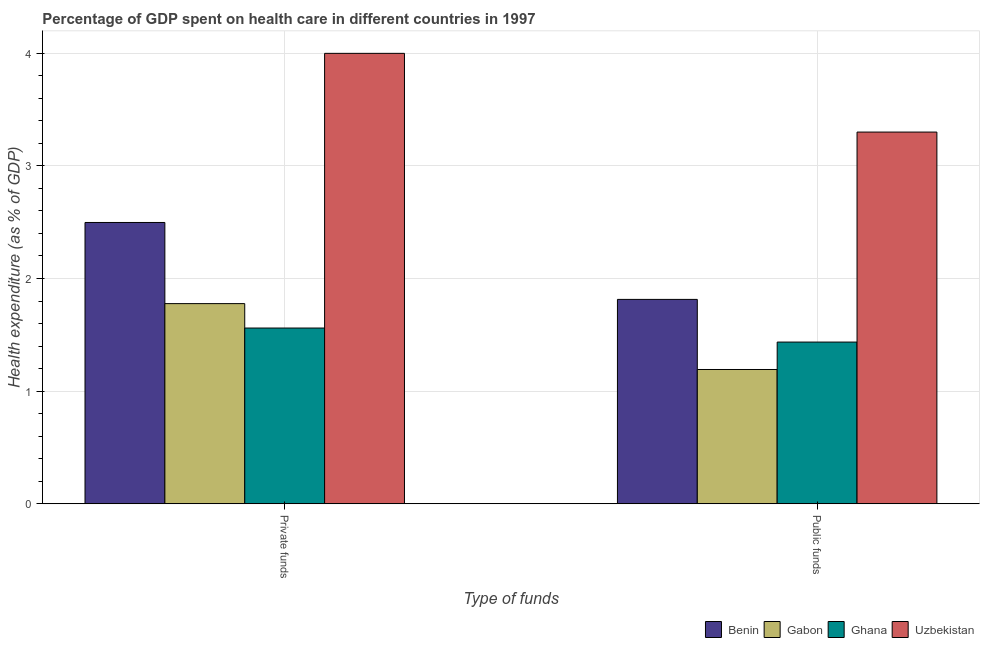How many different coloured bars are there?
Your response must be concise. 4. Are the number of bars per tick equal to the number of legend labels?
Provide a succinct answer. Yes. Are the number of bars on each tick of the X-axis equal?
Give a very brief answer. Yes. How many bars are there on the 2nd tick from the left?
Make the answer very short. 4. What is the label of the 2nd group of bars from the left?
Provide a succinct answer. Public funds. What is the amount of private funds spent in healthcare in Uzbekistan?
Your response must be concise. 4. Across all countries, what is the maximum amount of private funds spent in healthcare?
Ensure brevity in your answer.  4. Across all countries, what is the minimum amount of public funds spent in healthcare?
Your response must be concise. 1.19. In which country was the amount of public funds spent in healthcare maximum?
Your answer should be compact. Uzbekistan. What is the total amount of public funds spent in healthcare in the graph?
Ensure brevity in your answer.  7.74. What is the difference between the amount of private funds spent in healthcare in Benin and that in Ghana?
Give a very brief answer. 0.94. What is the difference between the amount of public funds spent in healthcare in Benin and the amount of private funds spent in healthcare in Uzbekistan?
Make the answer very short. -2.18. What is the average amount of public funds spent in healthcare per country?
Keep it short and to the point. 1.94. What is the difference between the amount of public funds spent in healthcare and amount of private funds spent in healthcare in Benin?
Ensure brevity in your answer.  -0.68. In how many countries, is the amount of private funds spent in healthcare greater than 2.6 %?
Provide a succinct answer. 1. What is the ratio of the amount of public funds spent in healthcare in Ghana to that in Benin?
Offer a terse response. 0.79. Is the amount of private funds spent in healthcare in Ghana less than that in Benin?
Keep it short and to the point. Yes. In how many countries, is the amount of public funds spent in healthcare greater than the average amount of public funds spent in healthcare taken over all countries?
Offer a terse response. 1. What does the 2nd bar from the left in Public funds represents?
Ensure brevity in your answer.  Gabon. What does the 3rd bar from the right in Private funds represents?
Ensure brevity in your answer.  Gabon. Are all the bars in the graph horizontal?
Provide a succinct answer. No. How many countries are there in the graph?
Offer a terse response. 4. Does the graph contain grids?
Offer a very short reply. Yes. Where does the legend appear in the graph?
Provide a succinct answer. Bottom right. How many legend labels are there?
Give a very brief answer. 4. How are the legend labels stacked?
Provide a succinct answer. Horizontal. What is the title of the graph?
Give a very brief answer. Percentage of GDP spent on health care in different countries in 1997. Does "Czech Republic" appear as one of the legend labels in the graph?
Provide a short and direct response. No. What is the label or title of the X-axis?
Your answer should be compact. Type of funds. What is the label or title of the Y-axis?
Provide a short and direct response. Health expenditure (as % of GDP). What is the Health expenditure (as % of GDP) of Benin in Private funds?
Ensure brevity in your answer.  2.5. What is the Health expenditure (as % of GDP) in Gabon in Private funds?
Your answer should be compact. 1.78. What is the Health expenditure (as % of GDP) in Ghana in Private funds?
Your response must be concise. 1.56. What is the Health expenditure (as % of GDP) of Uzbekistan in Private funds?
Offer a terse response. 4. What is the Health expenditure (as % of GDP) in Benin in Public funds?
Give a very brief answer. 1.81. What is the Health expenditure (as % of GDP) in Gabon in Public funds?
Your answer should be very brief. 1.19. What is the Health expenditure (as % of GDP) of Ghana in Public funds?
Provide a short and direct response. 1.44. What is the Health expenditure (as % of GDP) in Uzbekistan in Public funds?
Give a very brief answer. 3.3. Across all Type of funds, what is the maximum Health expenditure (as % of GDP) of Benin?
Keep it short and to the point. 2.5. Across all Type of funds, what is the maximum Health expenditure (as % of GDP) of Gabon?
Offer a terse response. 1.78. Across all Type of funds, what is the maximum Health expenditure (as % of GDP) in Ghana?
Keep it short and to the point. 1.56. Across all Type of funds, what is the maximum Health expenditure (as % of GDP) in Uzbekistan?
Your answer should be very brief. 4. Across all Type of funds, what is the minimum Health expenditure (as % of GDP) in Benin?
Make the answer very short. 1.81. Across all Type of funds, what is the minimum Health expenditure (as % of GDP) in Gabon?
Offer a very short reply. 1.19. Across all Type of funds, what is the minimum Health expenditure (as % of GDP) in Ghana?
Provide a short and direct response. 1.44. Across all Type of funds, what is the minimum Health expenditure (as % of GDP) of Uzbekistan?
Your answer should be compact. 3.3. What is the total Health expenditure (as % of GDP) of Benin in the graph?
Your answer should be very brief. 4.31. What is the total Health expenditure (as % of GDP) of Gabon in the graph?
Give a very brief answer. 2.97. What is the total Health expenditure (as % of GDP) in Ghana in the graph?
Keep it short and to the point. 3. What is the total Health expenditure (as % of GDP) of Uzbekistan in the graph?
Your answer should be compact. 7.3. What is the difference between the Health expenditure (as % of GDP) in Benin in Private funds and that in Public funds?
Your answer should be very brief. 0.68. What is the difference between the Health expenditure (as % of GDP) in Gabon in Private funds and that in Public funds?
Ensure brevity in your answer.  0.58. What is the difference between the Health expenditure (as % of GDP) in Ghana in Private funds and that in Public funds?
Provide a succinct answer. 0.12. What is the difference between the Health expenditure (as % of GDP) in Uzbekistan in Private funds and that in Public funds?
Your answer should be very brief. 0.7. What is the difference between the Health expenditure (as % of GDP) in Benin in Private funds and the Health expenditure (as % of GDP) in Gabon in Public funds?
Provide a succinct answer. 1.31. What is the difference between the Health expenditure (as % of GDP) of Benin in Private funds and the Health expenditure (as % of GDP) of Ghana in Public funds?
Offer a terse response. 1.06. What is the difference between the Health expenditure (as % of GDP) in Benin in Private funds and the Health expenditure (as % of GDP) in Uzbekistan in Public funds?
Offer a very short reply. -0.8. What is the difference between the Health expenditure (as % of GDP) in Gabon in Private funds and the Health expenditure (as % of GDP) in Ghana in Public funds?
Your answer should be compact. 0.34. What is the difference between the Health expenditure (as % of GDP) in Gabon in Private funds and the Health expenditure (as % of GDP) in Uzbekistan in Public funds?
Make the answer very short. -1.52. What is the difference between the Health expenditure (as % of GDP) of Ghana in Private funds and the Health expenditure (as % of GDP) of Uzbekistan in Public funds?
Ensure brevity in your answer.  -1.74. What is the average Health expenditure (as % of GDP) of Benin per Type of funds?
Your answer should be very brief. 2.16. What is the average Health expenditure (as % of GDP) in Gabon per Type of funds?
Make the answer very short. 1.48. What is the average Health expenditure (as % of GDP) of Ghana per Type of funds?
Ensure brevity in your answer.  1.5. What is the average Health expenditure (as % of GDP) of Uzbekistan per Type of funds?
Make the answer very short. 3.65. What is the difference between the Health expenditure (as % of GDP) of Benin and Health expenditure (as % of GDP) of Gabon in Private funds?
Ensure brevity in your answer.  0.72. What is the difference between the Health expenditure (as % of GDP) in Benin and Health expenditure (as % of GDP) in Ghana in Private funds?
Provide a short and direct response. 0.94. What is the difference between the Health expenditure (as % of GDP) of Benin and Health expenditure (as % of GDP) of Uzbekistan in Private funds?
Keep it short and to the point. -1.5. What is the difference between the Health expenditure (as % of GDP) in Gabon and Health expenditure (as % of GDP) in Ghana in Private funds?
Ensure brevity in your answer.  0.22. What is the difference between the Health expenditure (as % of GDP) of Gabon and Health expenditure (as % of GDP) of Uzbekistan in Private funds?
Make the answer very short. -2.22. What is the difference between the Health expenditure (as % of GDP) of Ghana and Health expenditure (as % of GDP) of Uzbekistan in Private funds?
Ensure brevity in your answer.  -2.44. What is the difference between the Health expenditure (as % of GDP) of Benin and Health expenditure (as % of GDP) of Gabon in Public funds?
Ensure brevity in your answer.  0.62. What is the difference between the Health expenditure (as % of GDP) in Benin and Health expenditure (as % of GDP) in Ghana in Public funds?
Offer a terse response. 0.38. What is the difference between the Health expenditure (as % of GDP) in Benin and Health expenditure (as % of GDP) in Uzbekistan in Public funds?
Your answer should be very brief. -1.49. What is the difference between the Health expenditure (as % of GDP) of Gabon and Health expenditure (as % of GDP) of Ghana in Public funds?
Make the answer very short. -0.24. What is the difference between the Health expenditure (as % of GDP) of Gabon and Health expenditure (as % of GDP) of Uzbekistan in Public funds?
Provide a succinct answer. -2.11. What is the difference between the Health expenditure (as % of GDP) of Ghana and Health expenditure (as % of GDP) of Uzbekistan in Public funds?
Your answer should be compact. -1.86. What is the ratio of the Health expenditure (as % of GDP) in Benin in Private funds to that in Public funds?
Ensure brevity in your answer.  1.38. What is the ratio of the Health expenditure (as % of GDP) of Gabon in Private funds to that in Public funds?
Your answer should be compact. 1.49. What is the ratio of the Health expenditure (as % of GDP) in Ghana in Private funds to that in Public funds?
Ensure brevity in your answer.  1.09. What is the ratio of the Health expenditure (as % of GDP) of Uzbekistan in Private funds to that in Public funds?
Give a very brief answer. 1.21. What is the difference between the highest and the second highest Health expenditure (as % of GDP) in Benin?
Your answer should be very brief. 0.68. What is the difference between the highest and the second highest Health expenditure (as % of GDP) of Gabon?
Your answer should be very brief. 0.58. What is the difference between the highest and the second highest Health expenditure (as % of GDP) of Ghana?
Provide a short and direct response. 0.12. What is the difference between the highest and the second highest Health expenditure (as % of GDP) of Uzbekistan?
Your answer should be compact. 0.7. What is the difference between the highest and the lowest Health expenditure (as % of GDP) of Benin?
Your answer should be very brief. 0.68. What is the difference between the highest and the lowest Health expenditure (as % of GDP) of Gabon?
Give a very brief answer. 0.58. What is the difference between the highest and the lowest Health expenditure (as % of GDP) in Ghana?
Give a very brief answer. 0.12. What is the difference between the highest and the lowest Health expenditure (as % of GDP) in Uzbekistan?
Provide a succinct answer. 0.7. 